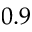<formula> <loc_0><loc_0><loc_500><loc_500>0 . 9</formula> 